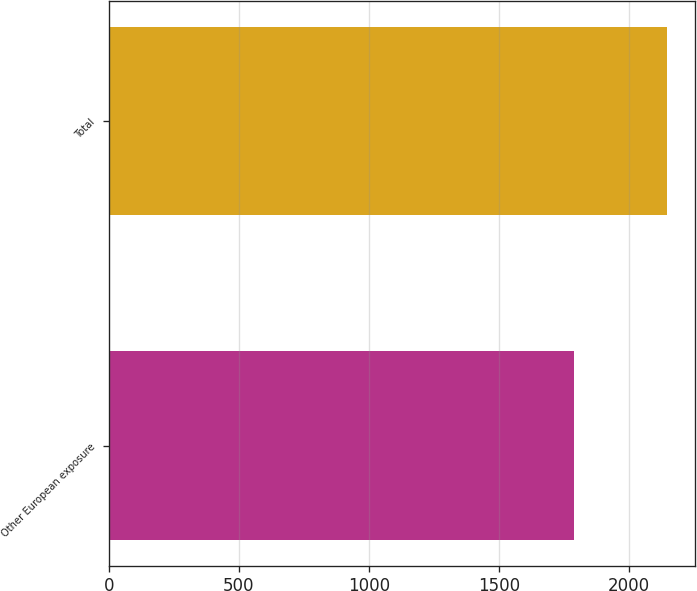Convert chart to OTSL. <chart><loc_0><loc_0><loc_500><loc_500><bar_chart><fcel>Other European exposure<fcel>Total<nl><fcel>1788<fcel>2146<nl></chart> 